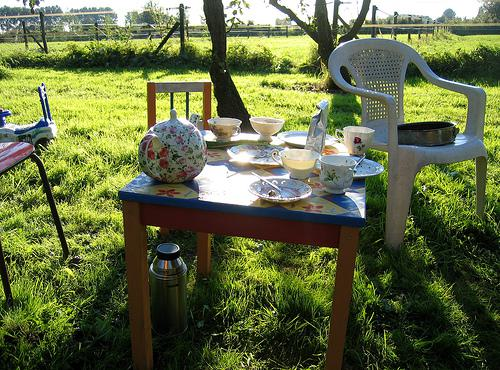Would there be a chair in the image if there was no chair in the image? No 